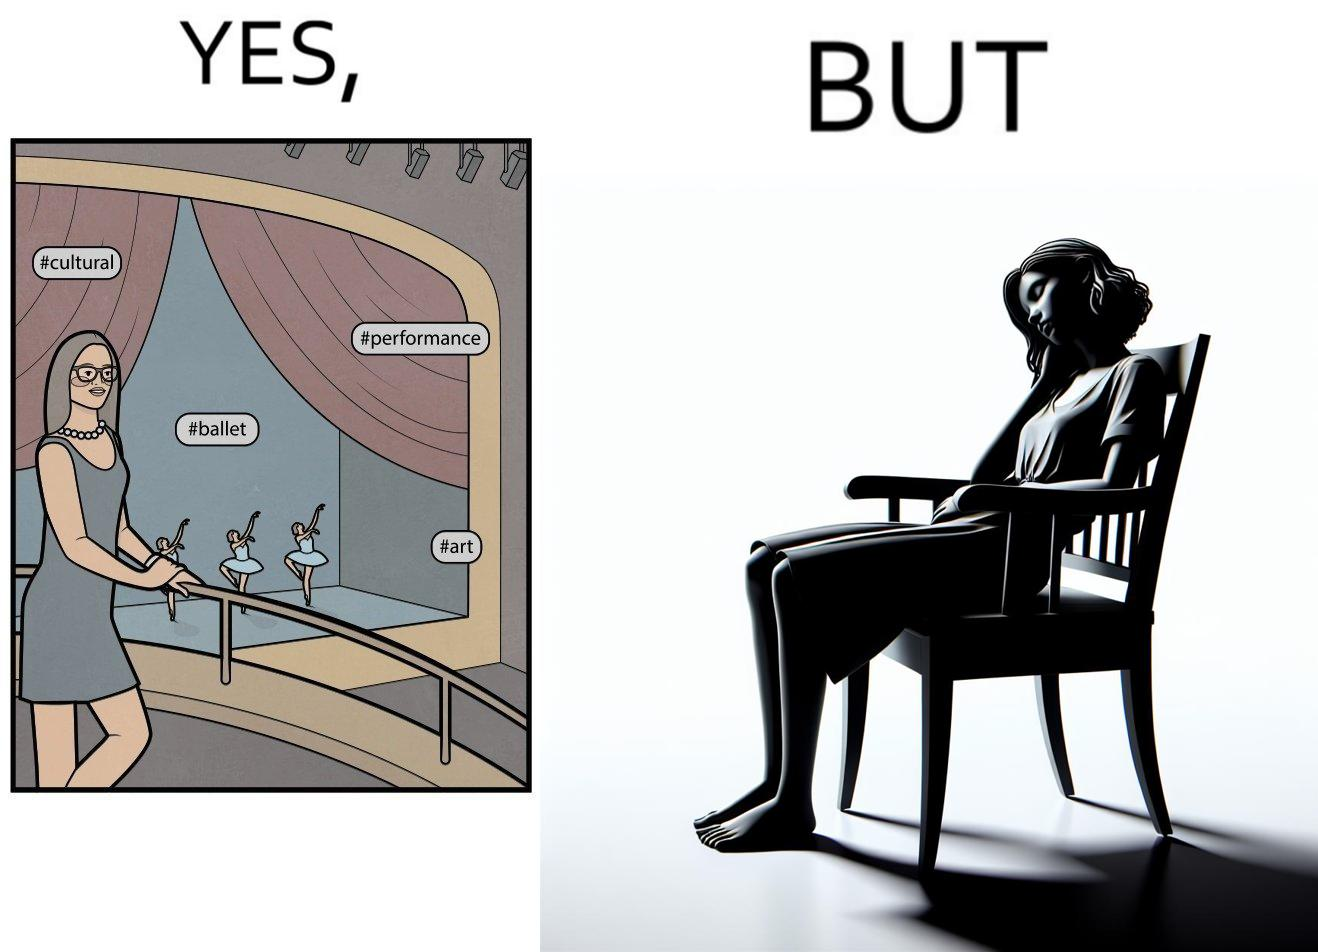Describe the contrast between the left and right parts of this image. In the left part of the image: a woman standing with some pose for photo at any auditorium with some program going on in her background at the stage with some hashtags written on the image at different places In the right part of the image: a woman sitting on a chair and sleeping with her mouth open 